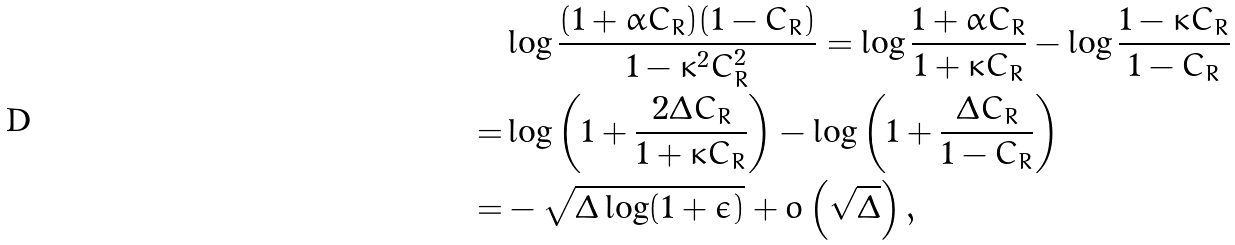Convert formula to latex. <formula><loc_0><loc_0><loc_500><loc_500>& \log \frac { ( 1 + \alpha C _ { R } ) ( 1 - C _ { R } ) } { 1 - \kappa ^ { 2 } C _ { R } ^ { 2 } } = \log \frac { 1 + \alpha C _ { R } } { 1 + \kappa C _ { R } } - \log \frac { 1 - \kappa C _ { R } } { 1 - C _ { R } } \\ = & \log \left ( 1 + \frac { 2 \Delta C _ { R } } { 1 + \kappa C _ { R } } \right ) - \log \left ( 1 + \frac { \Delta C _ { R } } { 1 - C _ { R } } \right ) \\ = & - \sqrt { \Delta \log ( 1 + \epsilon ) } + o \left ( \sqrt { \Delta } \right ) ,</formula> 